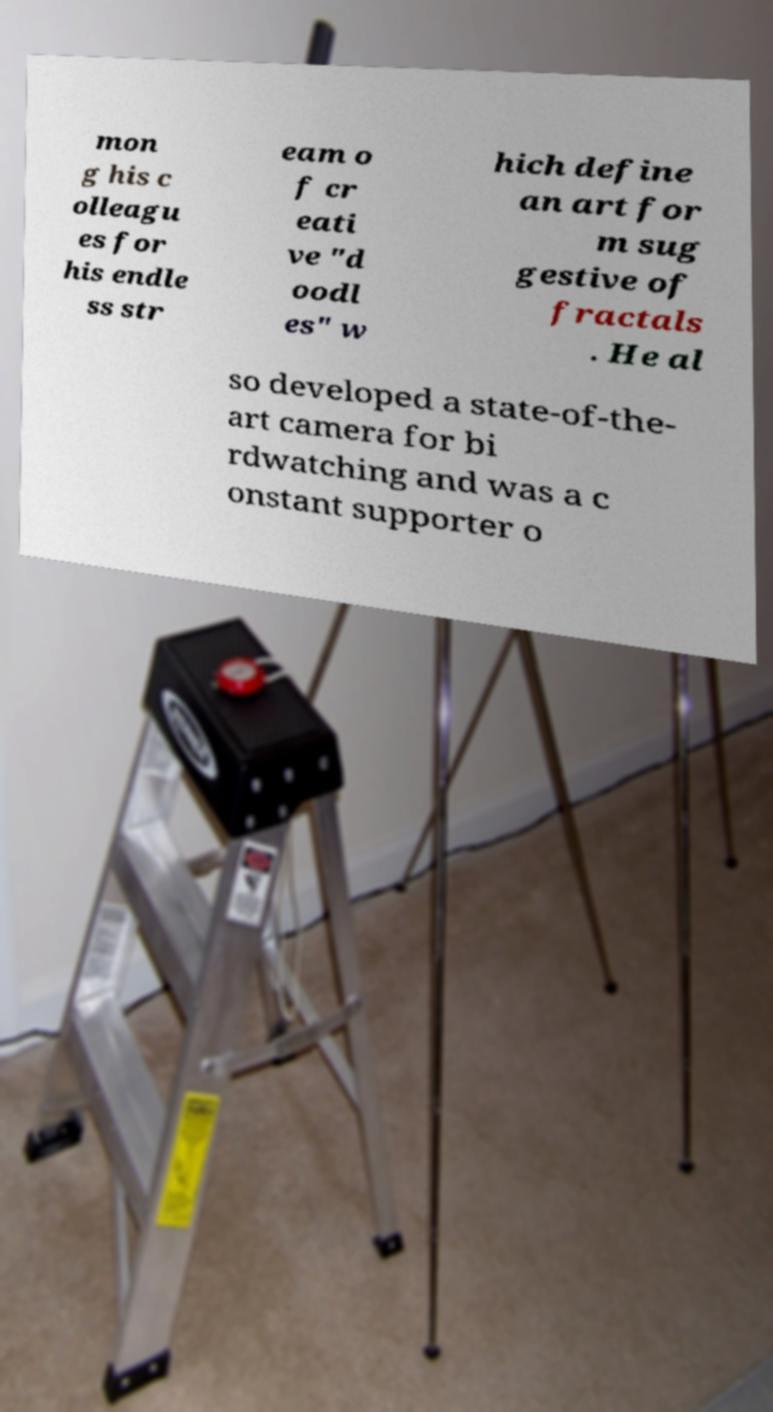For documentation purposes, I need the text within this image transcribed. Could you provide that? mon g his c olleagu es for his endle ss str eam o f cr eati ve "d oodl es" w hich define an art for m sug gestive of fractals . He al so developed a state-of-the- art camera for bi rdwatching and was a c onstant supporter o 